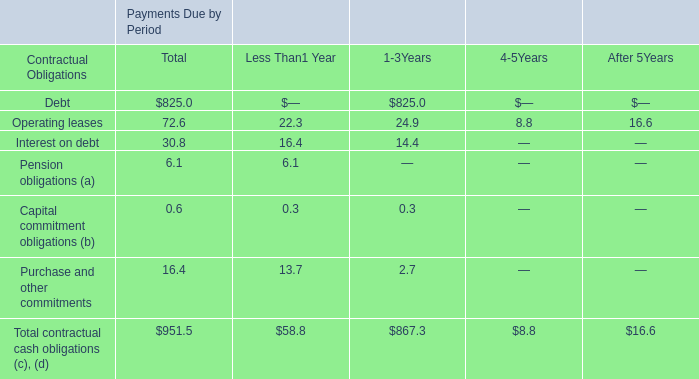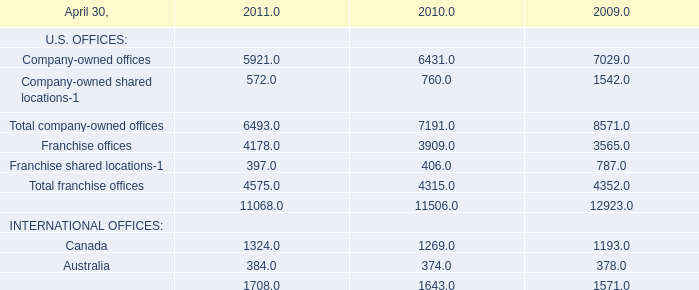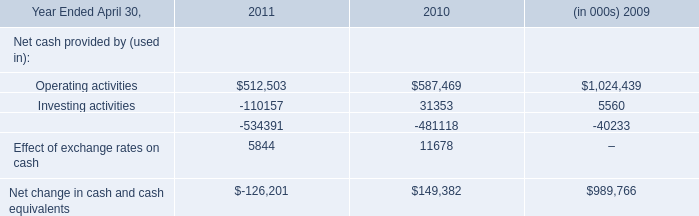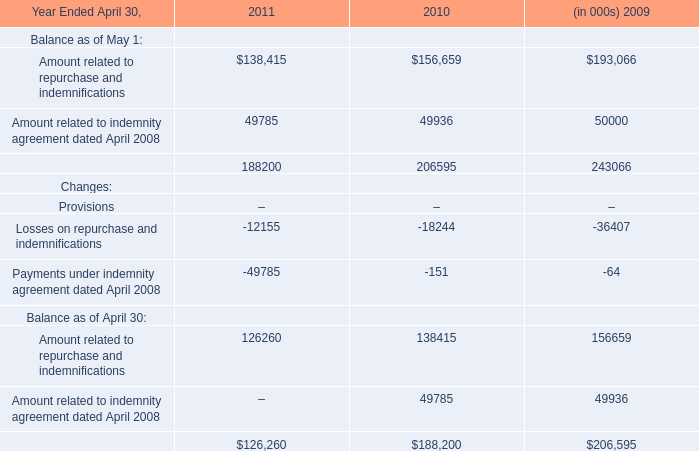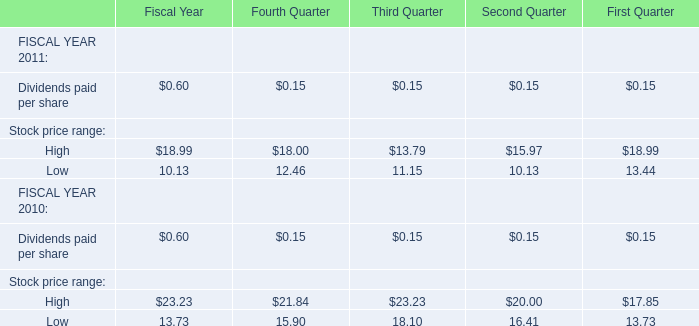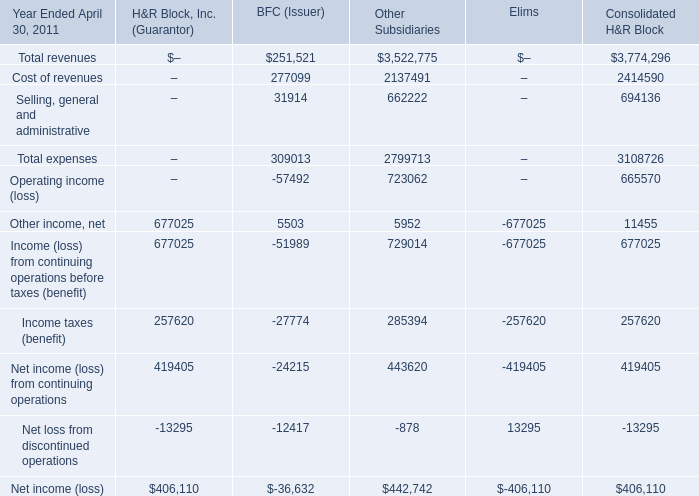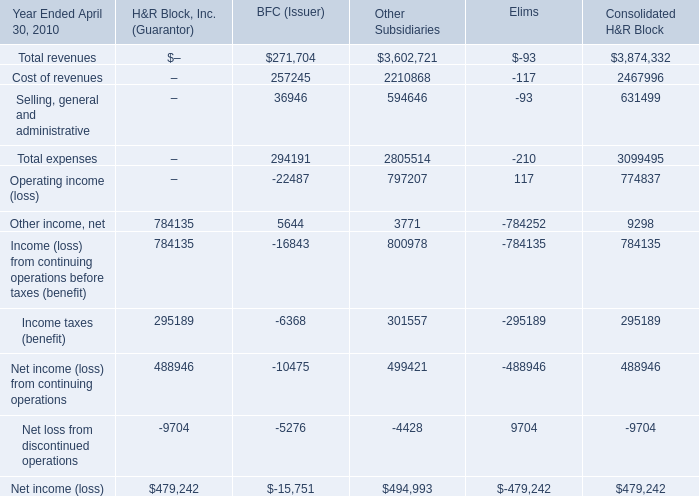In what sections is Other income, net positive for H&R Block, Inc. (Guarantor)? 
Answer: H&R Block, Inc. (Guarantor) and BFC (Issuer) and Other Subsidiaries. 